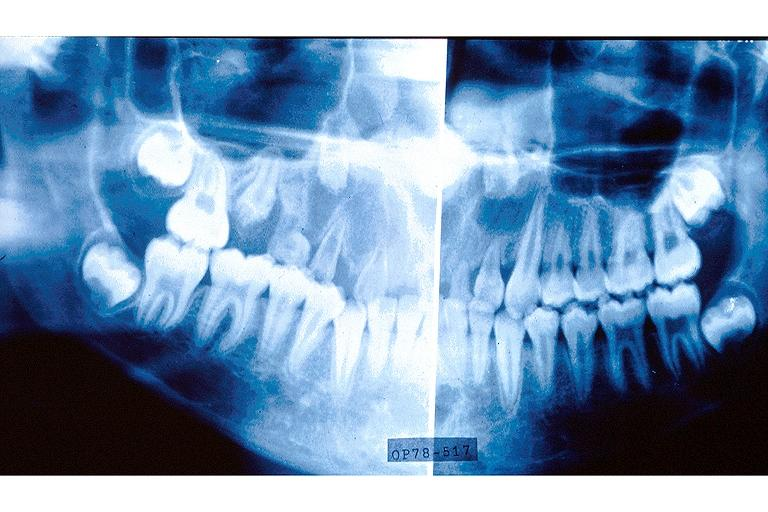does mesentery show regional odontodysplasia?
Answer the question using a single word or phrase. No 